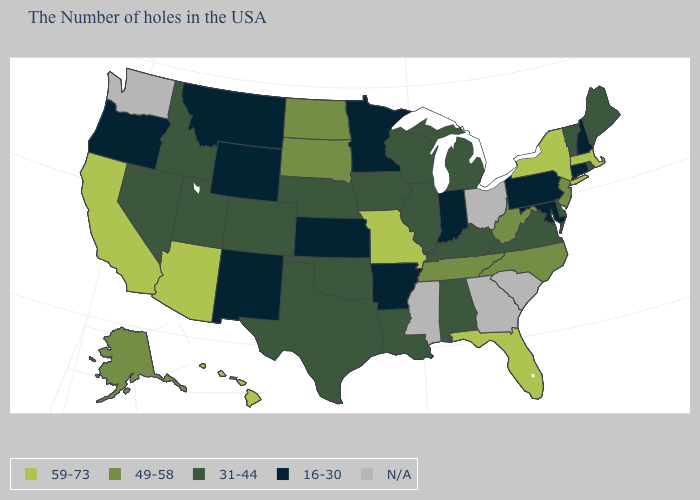What is the highest value in the USA?
Write a very short answer. 59-73. What is the lowest value in the USA?
Quick response, please. 16-30. Which states have the lowest value in the MidWest?
Answer briefly. Indiana, Minnesota, Kansas. What is the value of Colorado?
Short answer required. 31-44. Which states have the highest value in the USA?
Concise answer only. Massachusetts, New York, Florida, Missouri, Arizona, California, Hawaii. What is the value of Indiana?
Short answer required. 16-30. What is the lowest value in the USA?
Answer briefly. 16-30. Among the states that border Delaware , which have the highest value?
Answer briefly. New Jersey. How many symbols are there in the legend?
Quick response, please. 5. Among the states that border Florida , which have the lowest value?
Give a very brief answer. Alabama. Among the states that border Nebraska , does Missouri have the highest value?
Concise answer only. Yes. Which states hav the highest value in the West?
Answer briefly. Arizona, California, Hawaii. Among the states that border Louisiana , does Arkansas have the lowest value?
Answer briefly. Yes. Is the legend a continuous bar?
Keep it brief. No. What is the value of Oklahoma?
Short answer required. 31-44. 